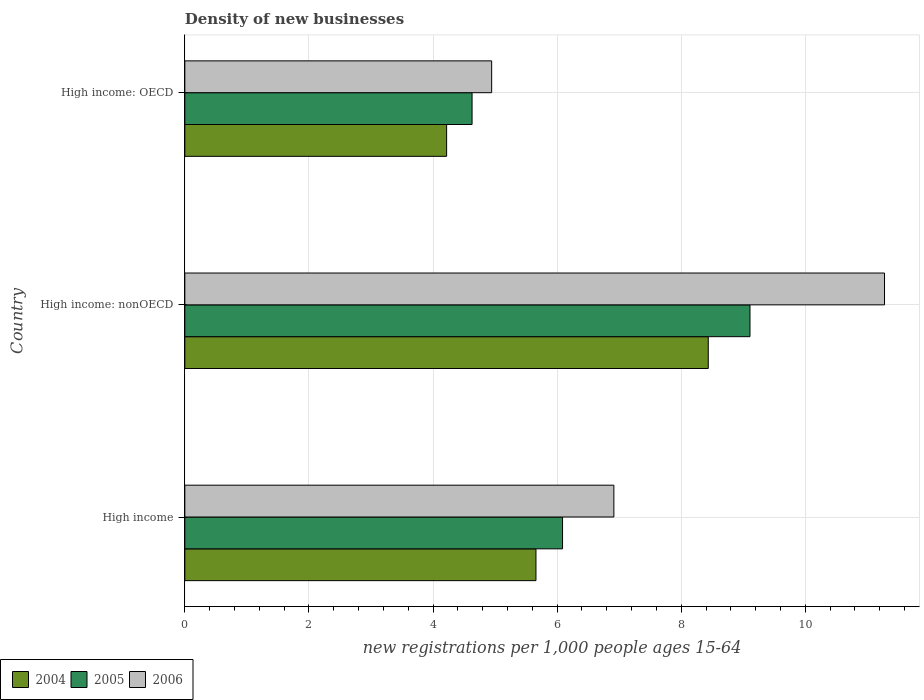How many groups of bars are there?
Your answer should be compact. 3. Are the number of bars per tick equal to the number of legend labels?
Keep it short and to the point. Yes. Are the number of bars on each tick of the Y-axis equal?
Offer a terse response. Yes. How many bars are there on the 2nd tick from the bottom?
Your answer should be very brief. 3. What is the number of new registrations in 2005 in High income: nonOECD?
Give a very brief answer. 9.11. Across all countries, what is the maximum number of new registrations in 2005?
Offer a very short reply. 9.11. Across all countries, what is the minimum number of new registrations in 2004?
Make the answer very short. 4.22. In which country was the number of new registrations in 2006 maximum?
Offer a very short reply. High income: nonOECD. In which country was the number of new registrations in 2006 minimum?
Give a very brief answer. High income: OECD. What is the total number of new registrations in 2006 in the graph?
Your answer should be very brief. 23.14. What is the difference between the number of new registrations in 2005 in High income and that in High income: nonOECD?
Your answer should be very brief. -3.02. What is the difference between the number of new registrations in 2006 in High income: OECD and the number of new registrations in 2004 in High income?
Your answer should be compact. -0.71. What is the average number of new registrations in 2005 per country?
Your answer should be compact. 6.61. What is the difference between the number of new registrations in 2005 and number of new registrations in 2006 in High income: OECD?
Your answer should be compact. -0.32. What is the ratio of the number of new registrations in 2005 in High income to that in High income: nonOECD?
Your answer should be very brief. 0.67. Is the number of new registrations in 2004 in High income: OECD less than that in High income: nonOECD?
Provide a short and direct response. Yes. Is the difference between the number of new registrations in 2005 in High income: OECD and High income: nonOECD greater than the difference between the number of new registrations in 2006 in High income: OECD and High income: nonOECD?
Your answer should be compact. Yes. What is the difference between the highest and the second highest number of new registrations in 2005?
Your answer should be very brief. 3.02. What is the difference between the highest and the lowest number of new registrations in 2006?
Keep it short and to the point. 6.33. In how many countries, is the number of new registrations in 2005 greater than the average number of new registrations in 2005 taken over all countries?
Your answer should be compact. 1. Is the sum of the number of new registrations in 2005 in High income and High income: nonOECD greater than the maximum number of new registrations in 2004 across all countries?
Provide a succinct answer. Yes. Is it the case that in every country, the sum of the number of new registrations in 2004 and number of new registrations in 2006 is greater than the number of new registrations in 2005?
Offer a terse response. Yes. How many bars are there?
Give a very brief answer. 9. How many countries are there in the graph?
Provide a short and direct response. 3. Does the graph contain any zero values?
Offer a very short reply. No. How many legend labels are there?
Your answer should be very brief. 3. How are the legend labels stacked?
Make the answer very short. Horizontal. What is the title of the graph?
Provide a succinct answer. Density of new businesses. What is the label or title of the X-axis?
Offer a very short reply. New registrations per 1,0 people ages 15-64. What is the new registrations per 1,000 people ages 15-64 of 2004 in High income?
Provide a succinct answer. 5.66. What is the new registrations per 1,000 people ages 15-64 of 2005 in High income?
Provide a succinct answer. 6.09. What is the new registrations per 1,000 people ages 15-64 of 2006 in High income?
Keep it short and to the point. 6.91. What is the new registrations per 1,000 people ages 15-64 in 2004 in High income: nonOECD?
Your response must be concise. 8.44. What is the new registrations per 1,000 people ages 15-64 of 2005 in High income: nonOECD?
Make the answer very short. 9.11. What is the new registrations per 1,000 people ages 15-64 of 2006 in High income: nonOECD?
Offer a very short reply. 11.28. What is the new registrations per 1,000 people ages 15-64 in 2004 in High income: OECD?
Your answer should be compact. 4.22. What is the new registrations per 1,000 people ages 15-64 in 2005 in High income: OECD?
Offer a terse response. 4.63. What is the new registrations per 1,000 people ages 15-64 in 2006 in High income: OECD?
Offer a terse response. 4.94. Across all countries, what is the maximum new registrations per 1,000 people ages 15-64 in 2004?
Provide a succinct answer. 8.44. Across all countries, what is the maximum new registrations per 1,000 people ages 15-64 in 2005?
Provide a short and direct response. 9.11. Across all countries, what is the maximum new registrations per 1,000 people ages 15-64 in 2006?
Ensure brevity in your answer.  11.28. Across all countries, what is the minimum new registrations per 1,000 people ages 15-64 in 2004?
Provide a succinct answer. 4.22. Across all countries, what is the minimum new registrations per 1,000 people ages 15-64 of 2005?
Give a very brief answer. 4.63. Across all countries, what is the minimum new registrations per 1,000 people ages 15-64 in 2006?
Keep it short and to the point. 4.94. What is the total new registrations per 1,000 people ages 15-64 of 2004 in the graph?
Provide a short and direct response. 18.31. What is the total new registrations per 1,000 people ages 15-64 in 2005 in the graph?
Offer a terse response. 19.82. What is the total new registrations per 1,000 people ages 15-64 of 2006 in the graph?
Offer a terse response. 23.14. What is the difference between the new registrations per 1,000 people ages 15-64 of 2004 in High income and that in High income: nonOECD?
Offer a very short reply. -2.78. What is the difference between the new registrations per 1,000 people ages 15-64 in 2005 in High income and that in High income: nonOECD?
Offer a very short reply. -3.02. What is the difference between the new registrations per 1,000 people ages 15-64 of 2006 in High income and that in High income: nonOECD?
Make the answer very short. -4.36. What is the difference between the new registrations per 1,000 people ages 15-64 in 2004 in High income and that in High income: OECD?
Make the answer very short. 1.44. What is the difference between the new registrations per 1,000 people ages 15-64 in 2005 in High income and that in High income: OECD?
Your response must be concise. 1.46. What is the difference between the new registrations per 1,000 people ages 15-64 of 2006 in High income and that in High income: OECD?
Your answer should be compact. 1.97. What is the difference between the new registrations per 1,000 people ages 15-64 of 2004 in High income: nonOECD and that in High income: OECD?
Give a very brief answer. 4.22. What is the difference between the new registrations per 1,000 people ages 15-64 in 2005 in High income: nonOECD and that in High income: OECD?
Offer a terse response. 4.48. What is the difference between the new registrations per 1,000 people ages 15-64 in 2006 in High income: nonOECD and that in High income: OECD?
Keep it short and to the point. 6.33. What is the difference between the new registrations per 1,000 people ages 15-64 of 2004 in High income and the new registrations per 1,000 people ages 15-64 of 2005 in High income: nonOECD?
Give a very brief answer. -3.45. What is the difference between the new registrations per 1,000 people ages 15-64 of 2004 in High income and the new registrations per 1,000 people ages 15-64 of 2006 in High income: nonOECD?
Keep it short and to the point. -5.62. What is the difference between the new registrations per 1,000 people ages 15-64 in 2005 in High income and the new registrations per 1,000 people ages 15-64 in 2006 in High income: nonOECD?
Your answer should be compact. -5.19. What is the difference between the new registrations per 1,000 people ages 15-64 of 2004 in High income and the new registrations per 1,000 people ages 15-64 of 2005 in High income: OECD?
Offer a terse response. 1.03. What is the difference between the new registrations per 1,000 people ages 15-64 of 2004 in High income and the new registrations per 1,000 people ages 15-64 of 2006 in High income: OECD?
Your answer should be very brief. 0.71. What is the difference between the new registrations per 1,000 people ages 15-64 in 2005 in High income and the new registrations per 1,000 people ages 15-64 in 2006 in High income: OECD?
Offer a terse response. 1.14. What is the difference between the new registrations per 1,000 people ages 15-64 in 2004 in High income: nonOECD and the new registrations per 1,000 people ages 15-64 in 2005 in High income: OECD?
Give a very brief answer. 3.81. What is the difference between the new registrations per 1,000 people ages 15-64 in 2004 in High income: nonOECD and the new registrations per 1,000 people ages 15-64 in 2006 in High income: OECD?
Ensure brevity in your answer.  3.49. What is the difference between the new registrations per 1,000 people ages 15-64 in 2005 in High income: nonOECD and the new registrations per 1,000 people ages 15-64 in 2006 in High income: OECD?
Ensure brevity in your answer.  4.16. What is the average new registrations per 1,000 people ages 15-64 in 2004 per country?
Your answer should be very brief. 6.1. What is the average new registrations per 1,000 people ages 15-64 in 2005 per country?
Your answer should be compact. 6.61. What is the average new registrations per 1,000 people ages 15-64 of 2006 per country?
Your answer should be compact. 7.71. What is the difference between the new registrations per 1,000 people ages 15-64 of 2004 and new registrations per 1,000 people ages 15-64 of 2005 in High income?
Make the answer very short. -0.43. What is the difference between the new registrations per 1,000 people ages 15-64 of 2004 and new registrations per 1,000 people ages 15-64 of 2006 in High income?
Keep it short and to the point. -1.26. What is the difference between the new registrations per 1,000 people ages 15-64 of 2005 and new registrations per 1,000 people ages 15-64 of 2006 in High income?
Keep it short and to the point. -0.83. What is the difference between the new registrations per 1,000 people ages 15-64 in 2004 and new registrations per 1,000 people ages 15-64 in 2005 in High income: nonOECD?
Your answer should be compact. -0.67. What is the difference between the new registrations per 1,000 people ages 15-64 of 2004 and new registrations per 1,000 people ages 15-64 of 2006 in High income: nonOECD?
Provide a succinct answer. -2.84. What is the difference between the new registrations per 1,000 people ages 15-64 in 2005 and new registrations per 1,000 people ages 15-64 in 2006 in High income: nonOECD?
Keep it short and to the point. -2.17. What is the difference between the new registrations per 1,000 people ages 15-64 of 2004 and new registrations per 1,000 people ages 15-64 of 2005 in High income: OECD?
Your answer should be very brief. -0.41. What is the difference between the new registrations per 1,000 people ages 15-64 in 2004 and new registrations per 1,000 people ages 15-64 in 2006 in High income: OECD?
Your answer should be compact. -0.73. What is the difference between the new registrations per 1,000 people ages 15-64 in 2005 and new registrations per 1,000 people ages 15-64 in 2006 in High income: OECD?
Offer a terse response. -0.32. What is the ratio of the new registrations per 1,000 people ages 15-64 of 2004 in High income to that in High income: nonOECD?
Your answer should be very brief. 0.67. What is the ratio of the new registrations per 1,000 people ages 15-64 in 2005 in High income to that in High income: nonOECD?
Your response must be concise. 0.67. What is the ratio of the new registrations per 1,000 people ages 15-64 in 2006 in High income to that in High income: nonOECD?
Your answer should be very brief. 0.61. What is the ratio of the new registrations per 1,000 people ages 15-64 in 2004 in High income to that in High income: OECD?
Give a very brief answer. 1.34. What is the ratio of the new registrations per 1,000 people ages 15-64 in 2005 in High income to that in High income: OECD?
Offer a very short reply. 1.31. What is the ratio of the new registrations per 1,000 people ages 15-64 in 2006 in High income to that in High income: OECD?
Offer a very short reply. 1.4. What is the ratio of the new registrations per 1,000 people ages 15-64 in 2004 in High income: nonOECD to that in High income: OECD?
Offer a terse response. 2. What is the ratio of the new registrations per 1,000 people ages 15-64 of 2005 in High income: nonOECD to that in High income: OECD?
Ensure brevity in your answer.  1.97. What is the ratio of the new registrations per 1,000 people ages 15-64 of 2006 in High income: nonOECD to that in High income: OECD?
Your answer should be compact. 2.28. What is the difference between the highest and the second highest new registrations per 1,000 people ages 15-64 of 2004?
Offer a very short reply. 2.78. What is the difference between the highest and the second highest new registrations per 1,000 people ages 15-64 of 2005?
Your answer should be very brief. 3.02. What is the difference between the highest and the second highest new registrations per 1,000 people ages 15-64 in 2006?
Offer a terse response. 4.36. What is the difference between the highest and the lowest new registrations per 1,000 people ages 15-64 of 2004?
Offer a terse response. 4.22. What is the difference between the highest and the lowest new registrations per 1,000 people ages 15-64 of 2005?
Ensure brevity in your answer.  4.48. What is the difference between the highest and the lowest new registrations per 1,000 people ages 15-64 of 2006?
Give a very brief answer. 6.33. 